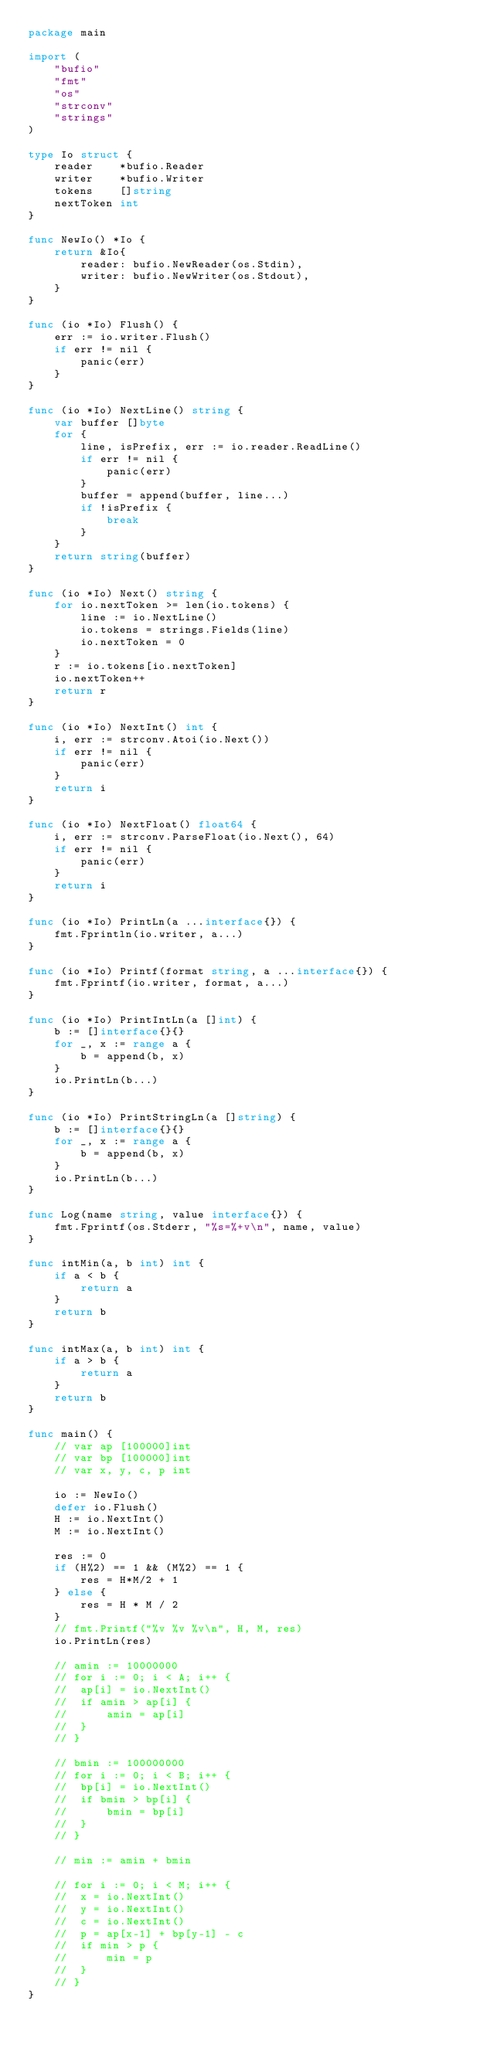<code> <loc_0><loc_0><loc_500><loc_500><_Go_>package main

import (
	"bufio"
	"fmt"
	"os"
	"strconv"
	"strings"
)

type Io struct {
	reader    *bufio.Reader
	writer    *bufio.Writer
	tokens    []string
	nextToken int
}

func NewIo() *Io {
	return &Io{
		reader: bufio.NewReader(os.Stdin),
		writer: bufio.NewWriter(os.Stdout),
	}
}

func (io *Io) Flush() {
	err := io.writer.Flush()
	if err != nil {
		panic(err)
	}
}

func (io *Io) NextLine() string {
	var buffer []byte
	for {
		line, isPrefix, err := io.reader.ReadLine()
		if err != nil {
			panic(err)
		}
		buffer = append(buffer, line...)
		if !isPrefix {
			break
		}
	}
	return string(buffer)
}

func (io *Io) Next() string {
	for io.nextToken >= len(io.tokens) {
		line := io.NextLine()
		io.tokens = strings.Fields(line)
		io.nextToken = 0
	}
	r := io.tokens[io.nextToken]
	io.nextToken++
	return r
}

func (io *Io) NextInt() int {
	i, err := strconv.Atoi(io.Next())
	if err != nil {
		panic(err)
	}
	return i
}

func (io *Io) NextFloat() float64 {
	i, err := strconv.ParseFloat(io.Next(), 64)
	if err != nil {
		panic(err)
	}
	return i
}

func (io *Io) PrintLn(a ...interface{}) {
	fmt.Fprintln(io.writer, a...)
}

func (io *Io) Printf(format string, a ...interface{}) {
	fmt.Fprintf(io.writer, format, a...)
}

func (io *Io) PrintIntLn(a []int) {
	b := []interface{}{}
	for _, x := range a {
		b = append(b, x)
	}
	io.PrintLn(b...)
}

func (io *Io) PrintStringLn(a []string) {
	b := []interface{}{}
	for _, x := range a {
		b = append(b, x)
	}
	io.PrintLn(b...)
}

func Log(name string, value interface{}) {
	fmt.Fprintf(os.Stderr, "%s=%+v\n", name, value)
}

func intMin(a, b int) int {
	if a < b {
		return a
	}
	return b
}

func intMax(a, b int) int {
	if a > b {
		return a
	}
	return b
}

func main() {
	// var ap [100000]int
	// var bp [100000]int
	// var x, y, c, p int

	io := NewIo()
	defer io.Flush()
	H := io.NextInt()
	M := io.NextInt()

	res := 0
	if (H%2) == 1 && (M%2) == 1 {
		res = H*M/2 + 1
	} else {
		res = H * M / 2
	}
	// fmt.Printf("%v %v %v\n", H, M, res)
	io.PrintLn(res)

	// amin := 10000000
	// for i := 0; i < A; i++ {
	// 	ap[i] = io.NextInt()
	// 	if amin > ap[i] {
	// 		amin = ap[i]
	// 	}
	// }

	// bmin := 100000000
	// for i := 0; i < B; i++ {
	// 	bp[i] = io.NextInt()
	// 	if bmin > bp[i] {
	// 		bmin = bp[i]
	// 	}
	// }

	// min := amin + bmin

	// for i := 0; i < M; i++ {
	// 	x = io.NextInt()
	// 	y = io.NextInt()
	// 	c = io.NextInt()
	// 	p = ap[x-1] + bp[y-1] - c
	// 	if min > p {
	// 		min = p
	// 	}
	// }
}
</code> 